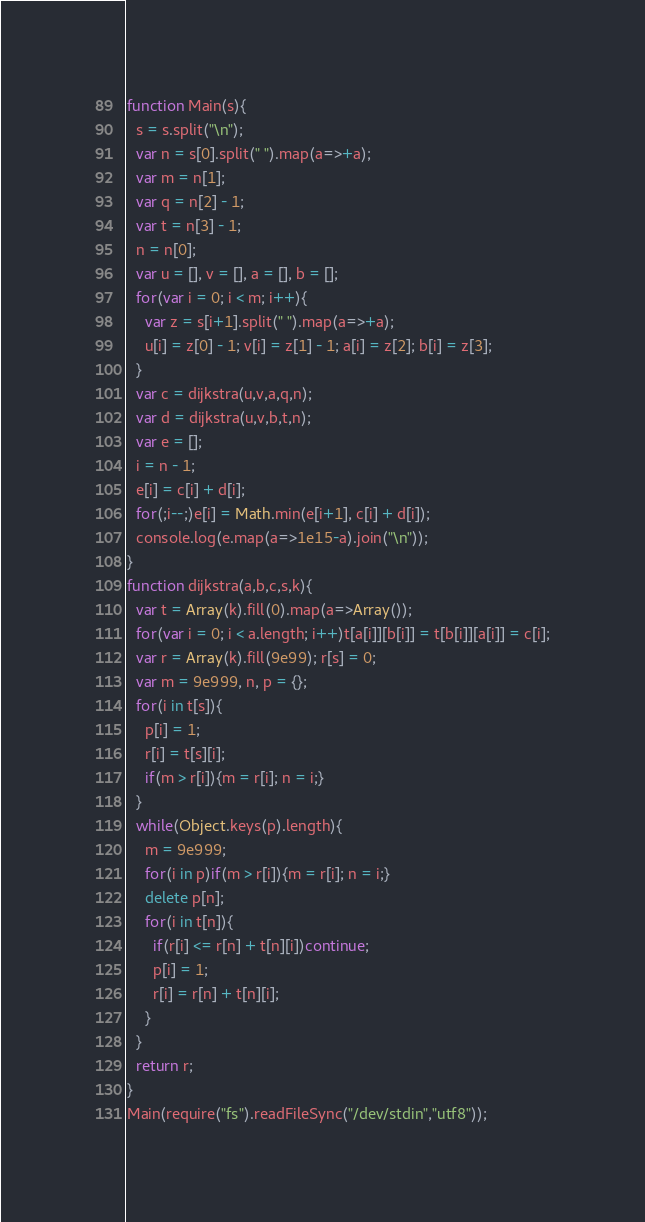<code> <loc_0><loc_0><loc_500><loc_500><_JavaScript_>function Main(s){
  s = s.split("\n");
  var n = s[0].split(" ").map(a=>+a);
  var m = n[1];
  var q = n[2] - 1;
  var t = n[3] - 1;
  n = n[0];
  var u = [], v = [], a = [], b = [];
  for(var i = 0; i < m; i++){
    var z = s[i+1].split(" ").map(a=>+a);
    u[i] = z[0] - 1; v[i] = z[1] - 1; a[i] = z[2]; b[i] = z[3];
  }
  var c = dijkstra(u,v,a,q,n);
  var d = dijkstra(u,v,b,t,n);
  var e = [];
  i = n - 1;
  e[i] = c[i] + d[i];
  for(;i--;)e[i] = Math.min(e[i+1], c[i] + d[i]);
  console.log(e.map(a=>1e15-a).join("\n"));
}
function dijkstra(a,b,c,s,k){
  var t = Array(k).fill(0).map(a=>Array());
  for(var i = 0; i < a.length; i++)t[a[i]][b[i]] = t[b[i]][a[i]] = c[i];
  var r = Array(k).fill(9e99); r[s] = 0;
  var m = 9e999, n, p = {};
  for(i in t[s]){
    p[i] = 1;
    r[i] = t[s][i];
    if(m > r[i]){m = r[i]; n = i;}
  }
  while(Object.keys(p).length){
    m = 9e999;
    for(i in p)if(m > r[i]){m = r[i]; n = i;}
    delete p[n];
    for(i in t[n]){
      if(r[i] <= r[n] + t[n][i])continue;
      p[i] = 1;
      r[i] = r[n] + t[n][i];
    }
  }
  return r;
}
Main(require("fs").readFileSync("/dev/stdin","utf8"));</code> 